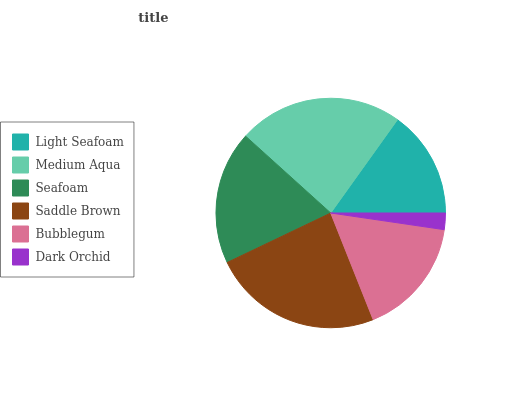Is Dark Orchid the minimum?
Answer yes or no. Yes. Is Saddle Brown the maximum?
Answer yes or no. Yes. Is Medium Aqua the minimum?
Answer yes or no. No. Is Medium Aqua the maximum?
Answer yes or no. No. Is Medium Aqua greater than Light Seafoam?
Answer yes or no. Yes. Is Light Seafoam less than Medium Aqua?
Answer yes or no. Yes. Is Light Seafoam greater than Medium Aqua?
Answer yes or no. No. Is Medium Aqua less than Light Seafoam?
Answer yes or no. No. Is Seafoam the high median?
Answer yes or no. Yes. Is Bubblegum the low median?
Answer yes or no. Yes. Is Dark Orchid the high median?
Answer yes or no. No. Is Light Seafoam the low median?
Answer yes or no. No. 